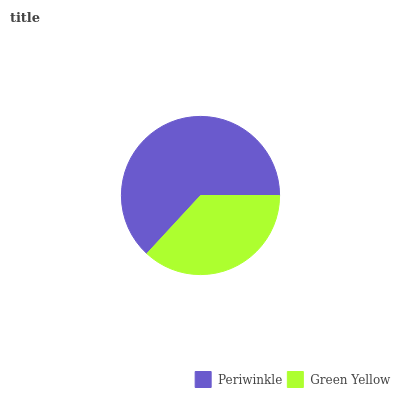Is Green Yellow the minimum?
Answer yes or no. Yes. Is Periwinkle the maximum?
Answer yes or no. Yes. Is Green Yellow the maximum?
Answer yes or no. No. Is Periwinkle greater than Green Yellow?
Answer yes or no. Yes. Is Green Yellow less than Periwinkle?
Answer yes or no. Yes. Is Green Yellow greater than Periwinkle?
Answer yes or no. No. Is Periwinkle less than Green Yellow?
Answer yes or no. No. Is Periwinkle the high median?
Answer yes or no. Yes. Is Green Yellow the low median?
Answer yes or no. Yes. Is Green Yellow the high median?
Answer yes or no. No. Is Periwinkle the low median?
Answer yes or no. No. 